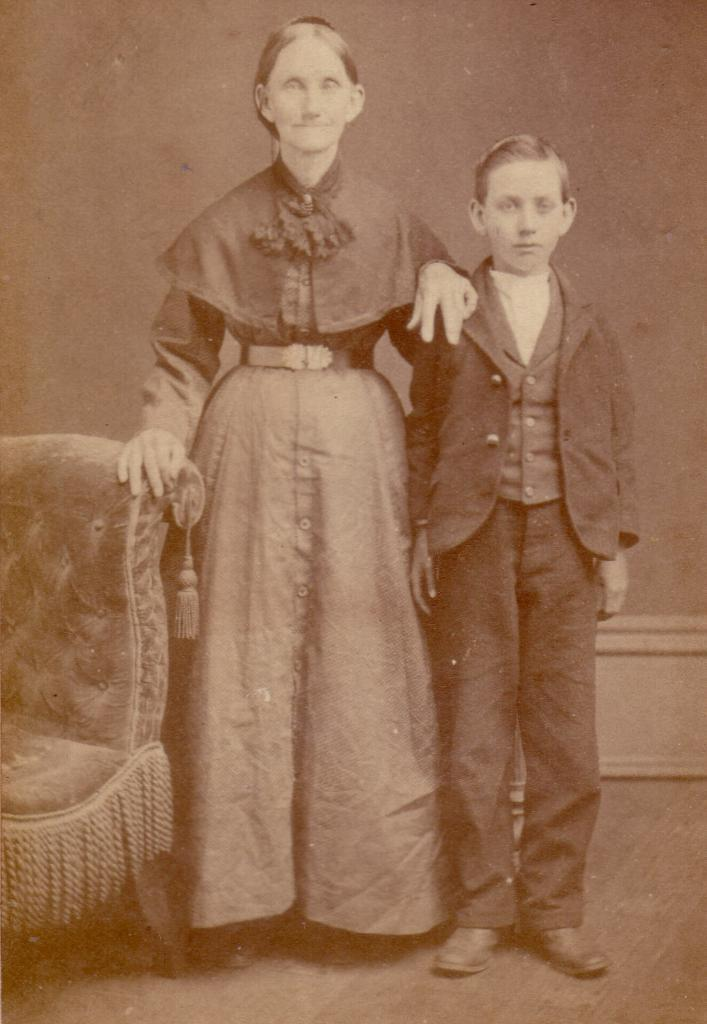How many people are in the image? There are two persons in the image. What is one person doing with her hands? One person is resting her hands on a chair. Can you describe the furniture in the image? There is a chair in the image. What type of surface can be seen at the bottom of the image? The ground is visible in the image. What is a vertical structure present in the image? There is a wall in the image. What type of tax is being discussed by the two persons in the image? There is no indication in the image that the two persons are discussing any type of tax. What type of ring can be seen on the finger of one of the persons in the image? There is no ring visible on the fingers of either person in the image. 